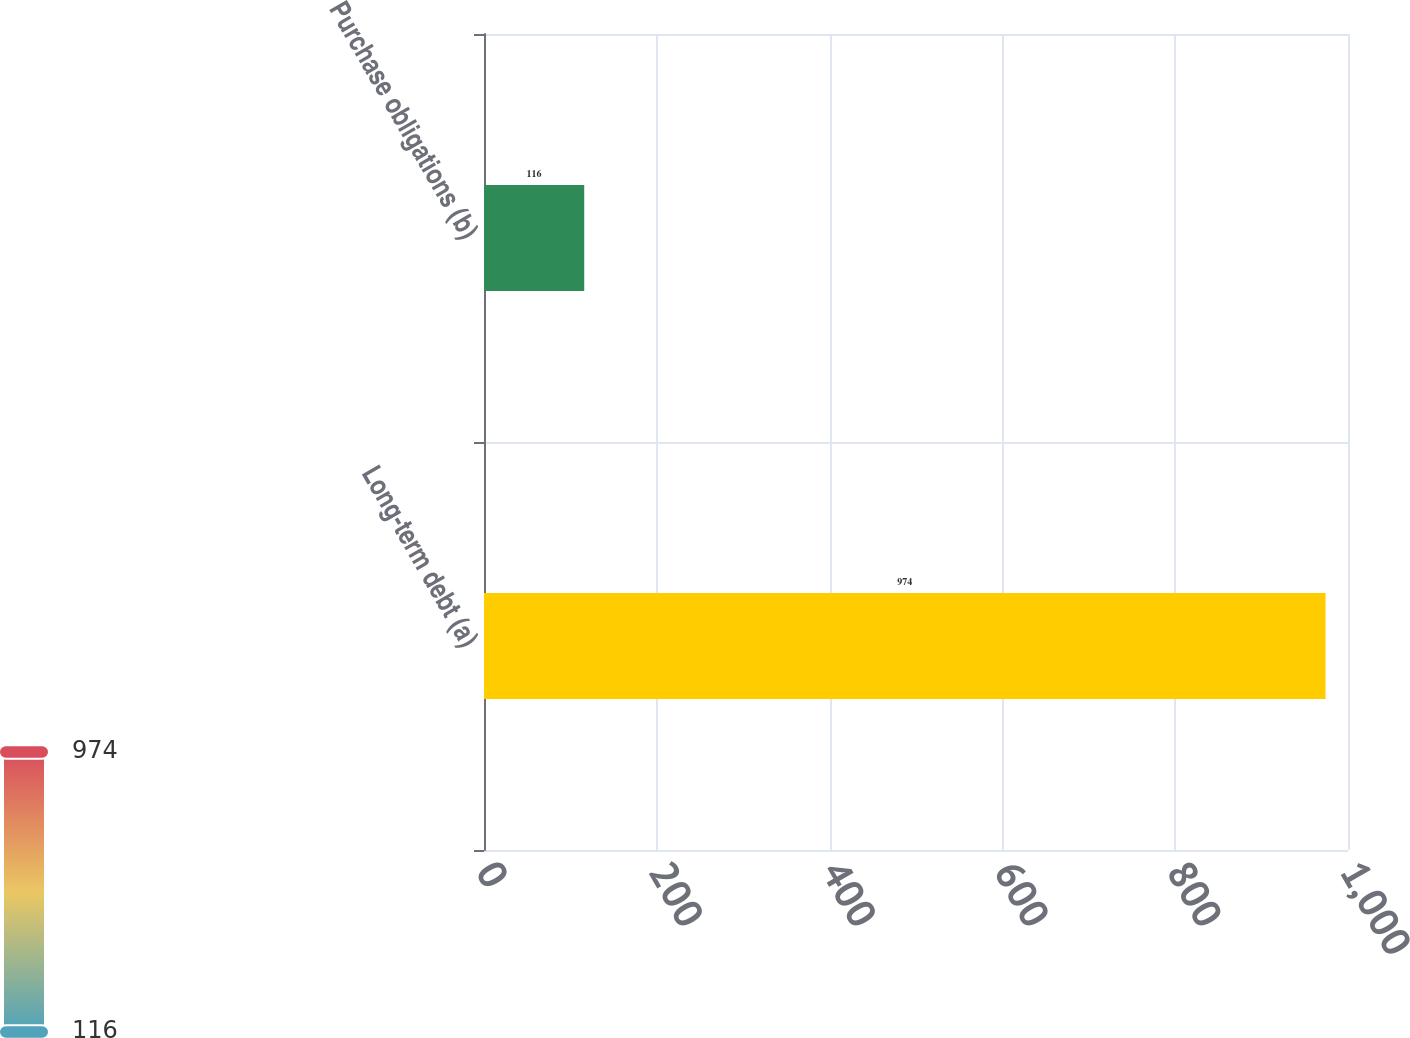Convert chart. <chart><loc_0><loc_0><loc_500><loc_500><bar_chart><fcel>Long-term debt (a)<fcel>Purchase obligations (b)<nl><fcel>974<fcel>116<nl></chart> 